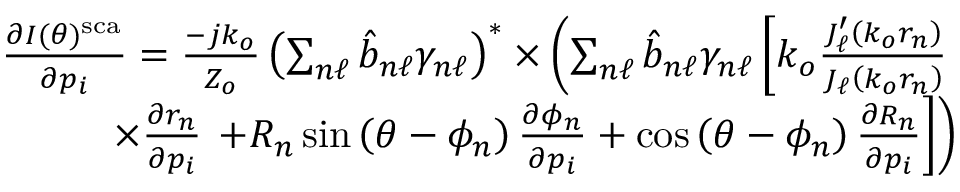Convert formula to latex. <formula><loc_0><loc_0><loc_500><loc_500>\begin{array} { r l r } & { \frac { \partial I ( \theta ) ^ { s c a } } { \partial p _ { i } } = \frac { - j k _ { o } } { Z _ { o } } \left ( \sum _ { n \ell } \hat { b } _ { n \ell } \gamma _ { n \ell } \right ) ^ { * } \times \left ( \sum _ { n \ell } \hat { b } _ { n \ell } \gamma _ { n \ell } \left [ k _ { o } \frac { J _ { \ell } ^ { \prime } \left ( k _ { o } r _ { n } \right ) } { J _ { \ell } \left ( k _ { o } r _ { n } \right ) } } \\ & { \times \frac { \partial r _ { n } } { \partial p _ { i } } + R _ { n } \sin \left ( \theta - \phi _ { n } \right ) \frac { \partial \phi _ { n } } { \partial p _ { i } } + \cos \left ( \theta - \phi _ { n } \right ) \frac { \partial R _ { n } } { \partial p _ { i } } \right ] \right ) } \end{array}</formula> 